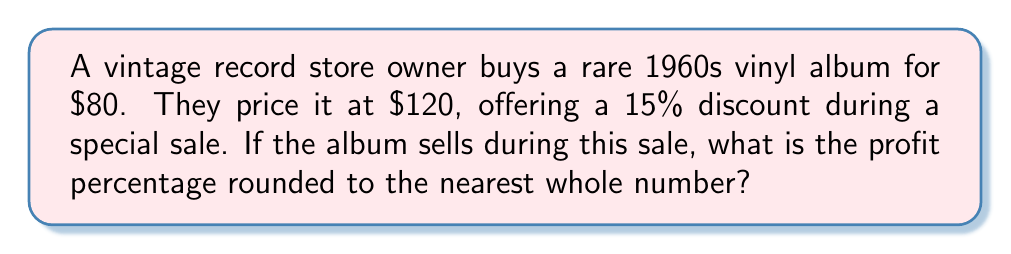Solve this math problem. Let's solve this step-by-step:

1. Calculate the sale price after the discount:
   $$ \text{Sale Price} = \text{Original Price} \times (1 - \text{Discount Percentage}) $$
   $$ \text{Sale Price} = $120 \times (1 - 0.15) = $120 \times 0.85 = $102 $$

2. Calculate the profit:
   $$ \text{Profit} = \text{Sale Price} - \text{Cost Price} $$
   $$ \text{Profit} = $102 - $80 = $22 $$

3. Calculate the profit percentage:
   $$ \text{Profit Percentage} = \frac{\text{Profit}}{\text{Cost Price}} \times 100\% $$
   $$ \text{Profit Percentage} = \frac{$22}{$80} \times 100\% = 0.275 \times 100\% = 27.5\% $$

4. Round to the nearest whole number:
   27.5% rounds to 28%
Answer: 28% 